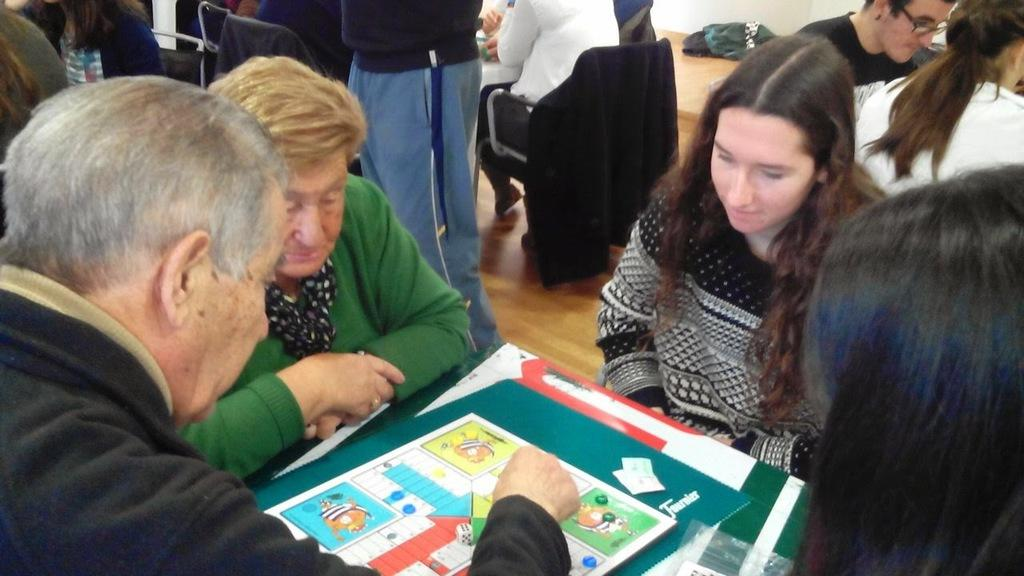What are the people in the image doing? There is a group of people sitting in chairs, and they are playing a Ludo game on a table. Can you describe the setting of the image? There is a group of people standing in the background, and there is a cloth and a table visible in the background. What type of base is supporting the wealth in the image? There is no mention of wealth or a base in the image; it features a group of people playing Ludo and the surrounding setting. 